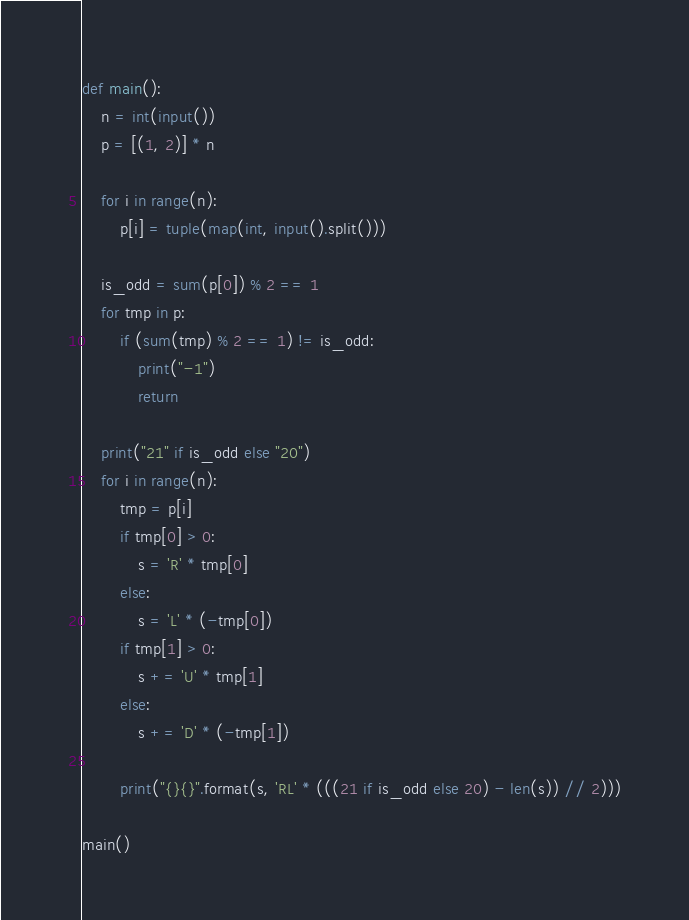<code> <loc_0><loc_0><loc_500><loc_500><_Python_>def main():
    n = int(input())
    p = [(1, 2)] * n

    for i in range(n):
        p[i] = tuple(map(int, input().split()))

    is_odd = sum(p[0]) % 2 == 1
    for tmp in p:
        if (sum(tmp) % 2 == 1) != is_odd:
            print("-1")
            return

    print("21" if is_odd else "20")
    for i in range(n):
        tmp = p[i]
        if tmp[0] > 0:
            s = 'R' * tmp[0]
        else:
            s = 'L' * (-tmp[0])
        if tmp[1] > 0:
            s += 'U' * tmp[1]
        else:
            s += 'D' * (-tmp[1])

        print("{}{}".format(s, 'RL' * (((21 if is_odd else 20) - len(s)) // 2)))

main()
</code> 